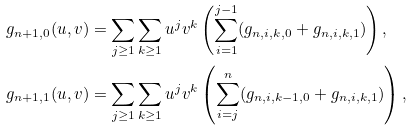<formula> <loc_0><loc_0><loc_500><loc_500>g _ { n + 1 , 0 } ( u , v ) & = \sum _ { j \geq 1 } \sum _ { k \geq 1 } u ^ { j } v ^ { k } \left ( \sum _ { i = 1 } ^ { j - 1 } ( g _ { n , i , k , 0 } + g _ { n , i , k , 1 } ) \right ) , \\ g _ { n + 1 , 1 } ( u , v ) & = \sum _ { j \geq 1 } \sum _ { k \geq 1 } u ^ { j } v ^ { k } \left ( \sum _ { i = j } ^ { n } ( g _ { n , i , k - 1 , 0 } + g _ { n , i , k , 1 } ) \right ) ,</formula> 